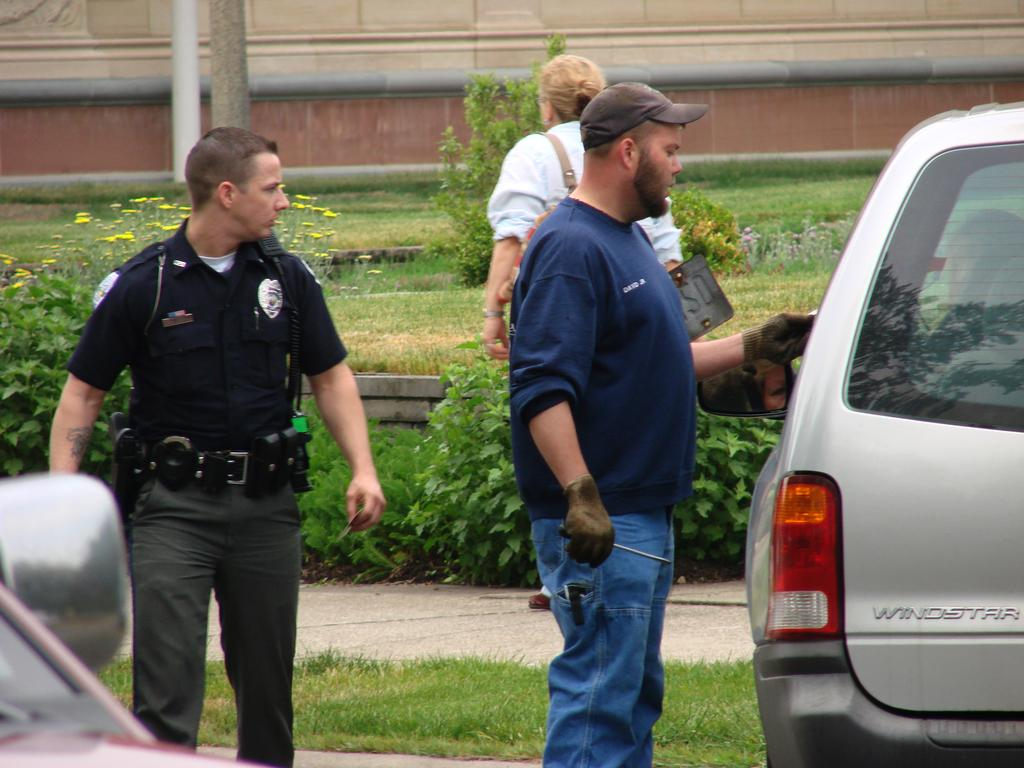How many people are in the image? There are people in the image, but the exact number is not specified. What is one person holding in the image? One person is holding a bag in the image. What else can be seen in the image besides people? There are vehicles, flowers near a plant, and grass visible in the image. What type of fuel is being used by the dinosaurs in the image? There are no dinosaurs present in the image, so it is not possible to determine what type of fuel they might be using. 